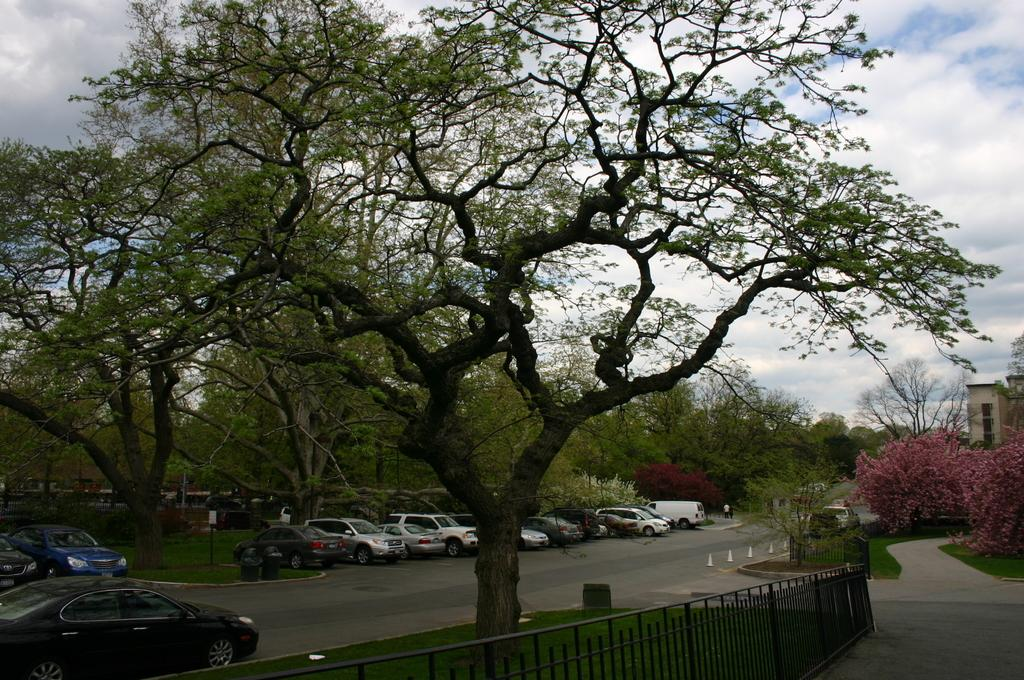What types of objects can be seen in the image? There are vehicles, trees, sign boards, and a fence at the bottom of the image. Can you describe the people in the image? There is a group of people in the image. What can be seen in the background of the image? There are flowers visible in the background, as well as a building. Where is the mailbox located in the image? There is no mailbox present in the image. What type of string is being used by the people in the image? There is no string visible in the image. 